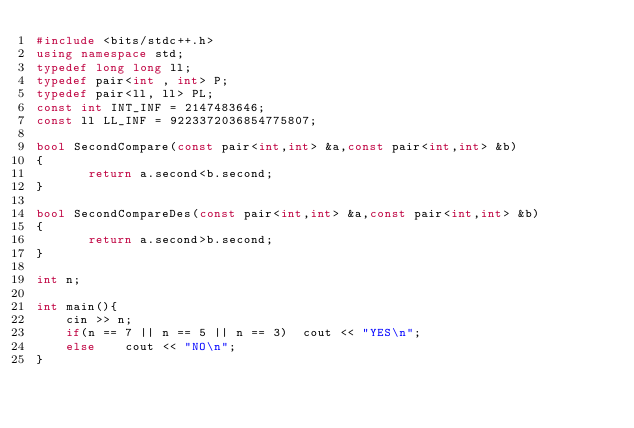Convert code to text. <code><loc_0><loc_0><loc_500><loc_500><_C++_>#include <bits/stdc++.h>
using namespace std;
typedef long long ll;
typedef pair<int , int> P;
typedef pair<ll, ll> PL;
const int INT_INF = 2147483646;
const ll LL_INF = 9223372036854775807;

bool SecondCompare(const pair<int,int> &a,const pair<int,int> &b)
{
       return a.second<b.second;
}
 
bool SecondCompareDes(const pair<int,int> &a,const pair<int,int> &b)
{
       return a.second>b.second;
}
 
int n;

int main(){
    cin >> n;
    if(n == 7 || n == 5 || n == 3)  cout << "YES\n";
    else    cout << "NO\n";
}</code> 